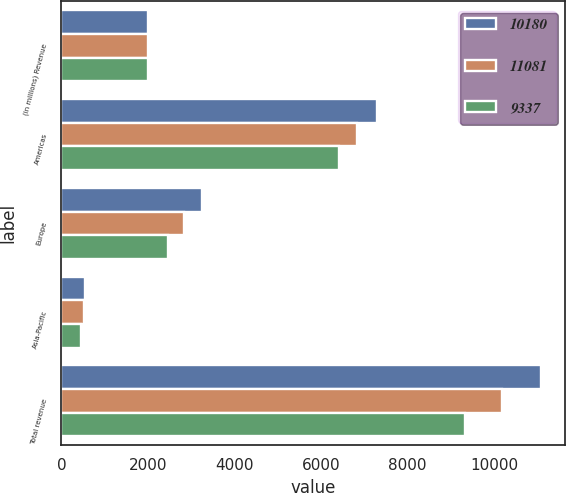Convert chart. <chart><loc_0><loc_0><loc_500><loc_500><stacked_bar_chart><ecel><fcel>(in millions) Revenue<fcel>Americas<fcel>Europe<fcel>Asia-Pacific<fcel>Total revenue<nl><fcel>10180<fcel>2014<fcel>7286<fcel>3246<fcel>549<fcel>11081<nl><fcel>11081<fcel>2013<fcel>6829<fcel>2832<fcel>519<fcel>10180<nl><fcel>9337<fcel>2012<fcel>6429<fcel>2460<fcel>448<fcel>9337<nl></chart> 